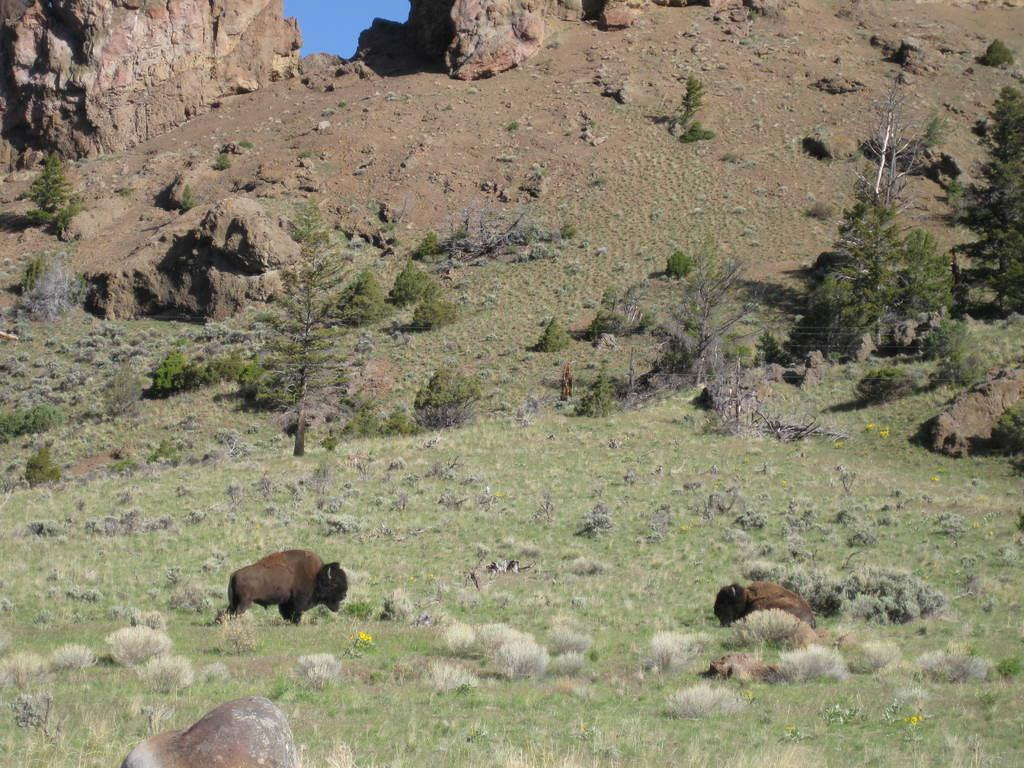What animals can be seen in the image? There are two yaks in the image. Where are the yaks located? The yaks are standing on the ground. What type of vegetation covers the ground? The ground is covered with grass. What can be seen in the background of the image? There are trees and hills visible in the image. What is the reaction of the yaks to the wall in the image? There is no wall present in the image, so the yaks' reaction cannot be determined. 